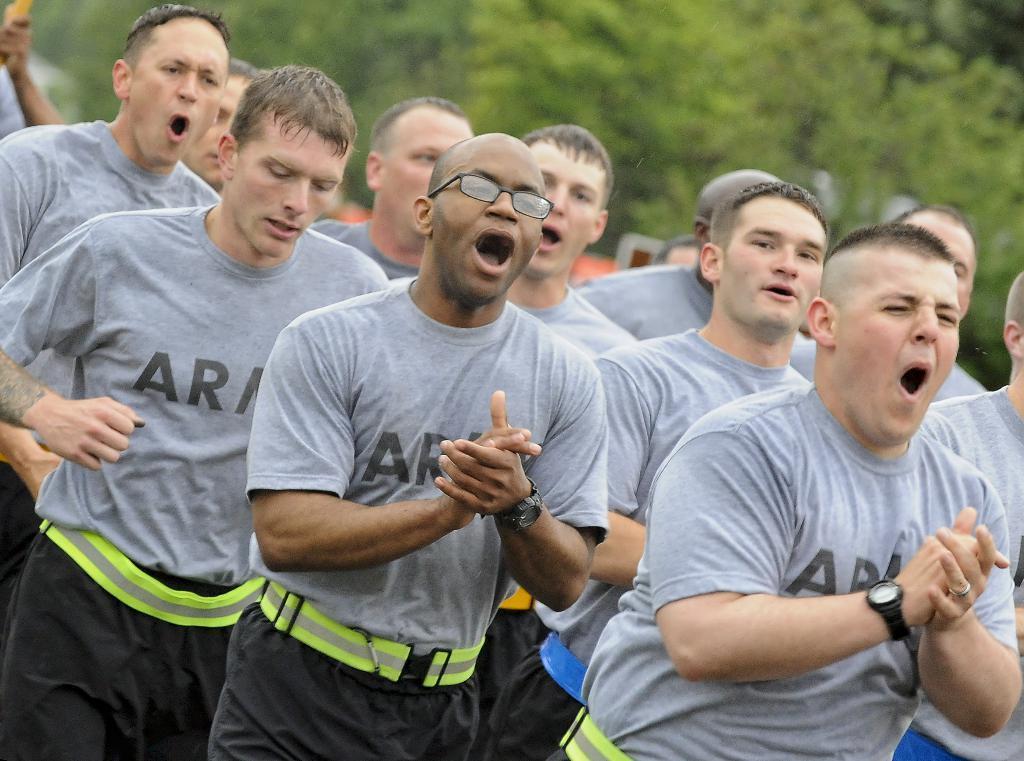Could you give a brief overview of what you see in this image? In this image I can see number of persons wearing grey t shirts and black pants are standing and in the background I can see few trees which are green in color and few other objects. 